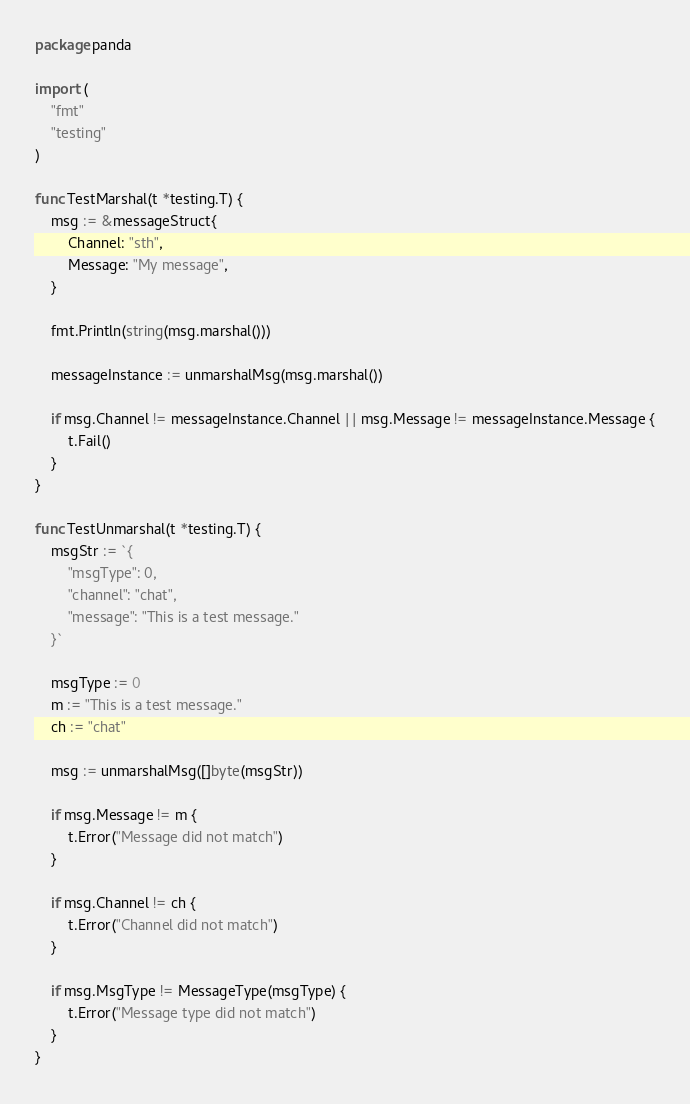<code> <loc_0><loc_0><loc_500><loc_500><_Go_>package panda

import (
	"fmt"
	"testing"
)

func TestMarshal(t *testing.T) {
	msg := &messageStruct{
		Channel: "sth",
		Message: "My message",
	}

	fmt.Println(string(msg.marshal()))

	messageInstance := unmarshalMsg(msg.marshal())

	if msg.Channel != messageInstance.Channel || msg.Message != messageInstance.Message {
		t.Fail()
	}
}

func TestUnmarshal(t *testing.T) {
	msgStr := `{
		"msgType": 0,
		"channel": "chat",
		"message": "This is a test message."
	}`

	msgType := 0
	m := "This is a test message."
	ch := "chat"

	msg := unmarshalMsg([]byte(msgStr))

	if msg.Message != m {
		t.Error("Message did not match")
	}

	if msg.Channel != ch {
		t.Error("Channel did not match")
	}

	if msg.MsgType != MessageType(msgType) {
		t.Error("Message type did not match")
	}
}
</code> 